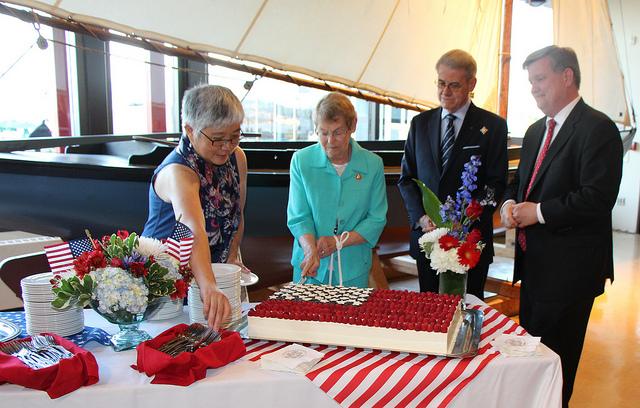This flags are from which country?
Keep it brief. Usa. What country do the colors represent?
Answer briefly. Usa. What occasion is being celebrated?
Answer briefly. 4th of july. What color is the suit?
Concise answer only. Black. 